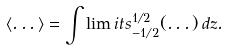<formula> <loc_0><loc_0><loc_500><loc_500>\langle \dots \rangle = \int \lim i t s _ { - 1 / 2 } ^ { 1 / 2 } ( \dots ) \, d z .</formula> 